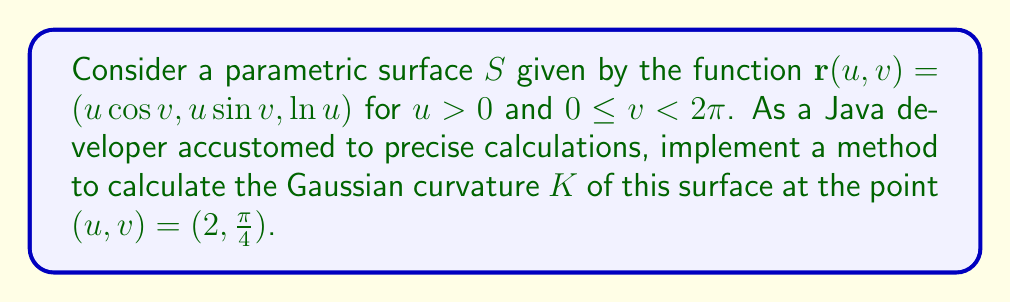Give your solution to this math problem. To calculate the Gaussian curvature, we'll follow these steps:

1. Calculate the partial derivatives:
   $$\mathbf{r}_u = (\cos v, \sin v, \frac{1}{u})$$
   $$\mathbf{r}_v = (-u\sin v, u\cos v, 0)$$

2. Calculate the second partial derivatives:
   $$\mathbf{r}_{uu} = (0, 0, -\frac{1}{u^2})$$
   $$\mathbf{r}_{uv} = (-\sin v, \cos v, 0)$$
   $$\mathbf{r}_{vv} = (-u\cos v, -u\sin v, 0)$$

3. Calculate the normal vector:
   $$\mathbf{N} = \frac{\mathbf{r}_u \times \mathbf{r}_v}{|\mathbf{r}_u \times \mathbf{r}_v|} = \frac{(-\sin v, -\cos v, u)}{\sqrt{u^2 + 1}}$$

4. Calculate the coefficients of the first fundamental form:
   $$E = \mathbf{r}_u \cdot \mathbf{r}_u = 1 + \frac{1}{u^2}$$
   $$F = \mathbf{r}_u \cdot \mathbf{r}_v = 0$$
   $$G = \mathbf{r}_v \cdot \mathbf{r}_v = u^2$$

5. Calculate the coefficients of the second fundamental form:
   $$L = \mathbf{r}_{uu} \cdot \mathbf{N} = \frac{1}{u\sqrt{u^2 + 1}}$$
   $$M = \mathbf{r}_{uv} \cdot \mathbf{N} = 0$$
   $$N = \mathbf{r}_{vv} \cdot \mathbf{N} = \frac{u}{\sqrt{u^2 + 1}}$$

6. Calculate the Gaussian curvature:
   $$K = \frac{LN - M^2}{EG - F^2} = \frac{\frac{1}{u\sqrt{u^2 + 1}} \cdot \frac{u}{\sqrt{u^2 + 1}} - 0^2}{(1 + \frac{1}{u^2}) \cdot u^2 - 0^2} = \frac{1}{u^2(u^2 + 1)}$$

7. Evaluate at the point $(u,v) = (2,\frac{\pi}{4})$:
   $$K = \frac{1}{2^2(2^2 + 1)} = \frac{1}{4(5)} = \frac{1}{20} = 0.05$$
Answer: $K = 0.05$ 